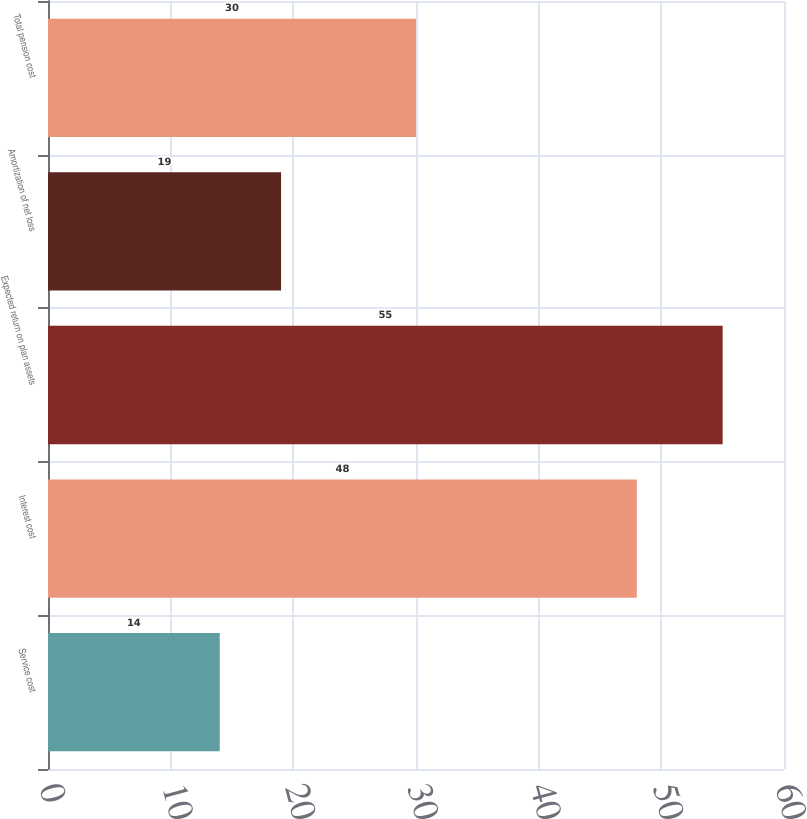Convert chart to OTSL. <chart><loc_0><loc_0><loc_500><loc_500><bar_chart><fcel>Service cost<fcel>Interest cost<fcel>Expected return on plan assets<fcel>Amortization of net loss<fcel>Total pension cost<nl><fcel>14<fcel>48<fcel>55<fcel>19<fcel>30<nl></chart> 